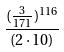Convert formula to latex. <formula><loc_0><loc_0><loc_500><loc_500>\frac { ( \frac { 3 } { 1 7 1 } ) ^ { 1 1 6 } } { ( 2 \cdot 1 0 ) }</formula> 